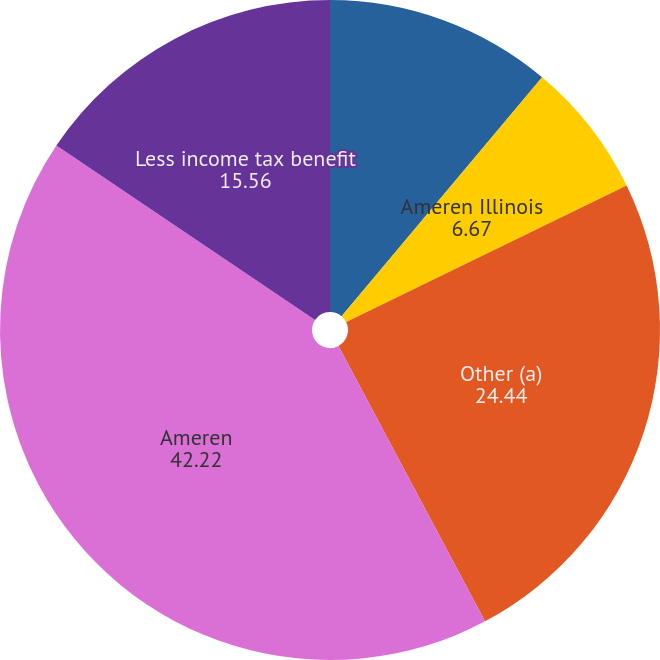Convert chart. <chart><loc_0><loc_0><loc_500><loc_500><pie_chart><fcel>Ameren Missouri<fcel>Ameren Illinois<fcel>Other (a)<fcel>Ameren<fcel>Less income tax benefit<nl><fcel>11.11%<fcel>6.67%<fcel>24.44%<fcel>42.22%<fcel>15.56%<nl></chart> 